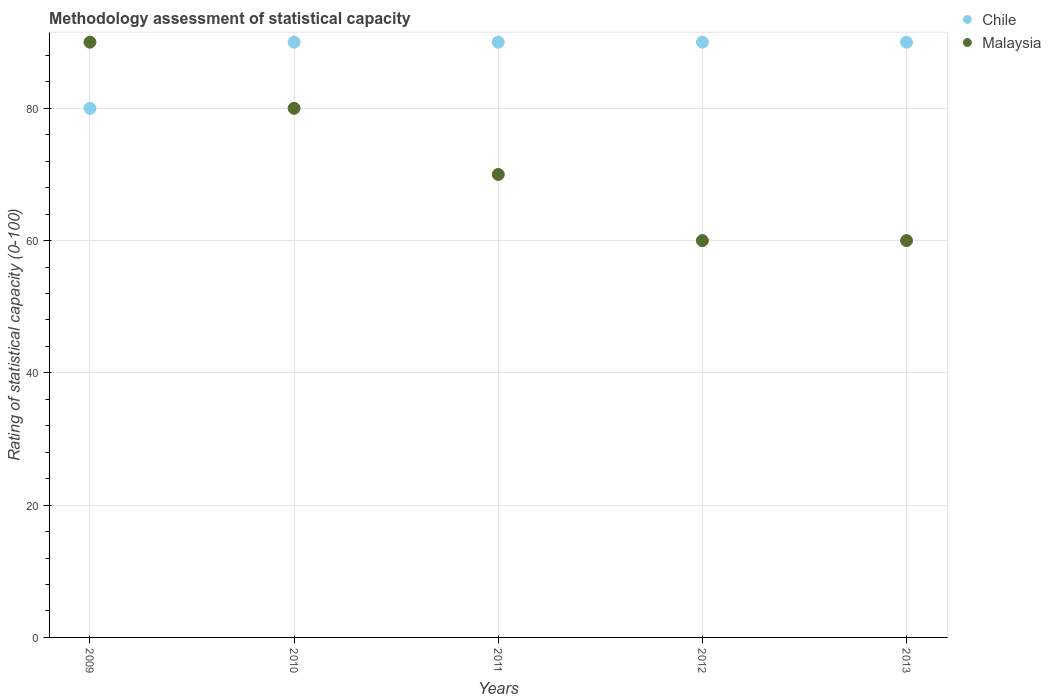How many different coloured dotlines are there?
Provide a succinct answer. 2. What is the rating of statistical capacity in Malaysia in 2011?
Keep it short and to the point. 70. Across all years, what is the maximum rating of statistical capacity in Malaysia?
Your answer should be very brief. 90. Across all years, what is the minimum rating of statistical capacity in Chile?
Ensure brevity in your answer.  80. In which year was the rating of statistical capacity in Malaysia maximum?
Ensure brevity in your answer.  2009. In which year was the rating of statistical capacity in Chile minimum?
Your answer should be very brief. 2009. What is the total rating of statistical capacity in Chile in the graph?
Give a very brief answer. 440. In the year 2011, what is the difference between the rating of statistical capacity in Chile and rating of statistical capacity in Malaysia?
Ensure brevity in your answer.  20. In how many years, is the rating of statistical capacity in Chile greater than 72?
Make the answer very short. 5. What is the ratio of the rating of statistical capacity in Chile in 2010 to that in 2013?
Provide a succinct answer. 1. Is the difference between the rating of statistical capacity in Chile in 2009 and 2012 greater than the difference between the rating of statistical capacity in Malaysia in 2009 and 2012?
Keep it short and to the point. No. What is the difference between the highest and the second highest rating of statistical capacity in Malaysia?
Give a very brief answer. 10. What is the difference between the highest and the lowest rating of statistical capacity in Chile?
Provide a succinct answer. 10. Is the sum of the rating of statistical capacity in Chile in 2009 and 2011 greater than the maximum rating of statistical capacity in Malaysia across all years?
Provide a succinct answer. Yes. Is the rating of statistical capacity in Malaysia strictly less than the rating of statistical capacity in Chile over the years?
Give a very brief answer. No. How many dotlines are there?
Provide a short and direct response. 2. Does the graph contain any zero values?
Give a very brief answer. No. Where does the legend appear in the graph?
Your answer should be very brief. Top right. How many legend labels are there?
Offer a terse response. 2. What is the title of the graph?
Make the answer very short. Methodology assessment of statistical capacity. Does "Burkina Faso" appear as one of the legend labels in the graph?
Your answer should be very brief. No. What is the label or title of the X-axis?
Give a very brief answer. Years. What is the label or title of the Y-axis?
Keep it short and to the point. Rating of statistical capacity (0-100). What is the Rating of statistical capacity (0-100) in Chile in 2009?
Your answer should be very brief. 80. What is the Rating of statistical capacity (0-100) in Malaysia in 2009?
Your answer should be very brief. 90. What is the Rating of statistical capacity (0-100) of Malaysia in 2010?
Ensure brevity in your answer.  80. What is the Rating of statistical capacity (0-100) in Malaysia in 2013?
Your answer should be very brief. 60. What is the total Rating of statistical capacity (0-100) of Chile in the graph?
Ensure brevity in your answer.  440. What is the total Rating of statistical capacity (0-100) of Malaysia in the graph?
Offer a very short reply. 360. What is the difference between the Rating of statistical capacity (0-100) of Malaysia in 2009 and that in 2010?
Give a very brief answer. 10. What is the difference between the Rating of statistical capacity (0-100) in Malaysia in 2009 and that in 2012?
Your answer should be very brief. 30. What is the difference between the Rating of statistical capacity (0-100) in Malaysia in 2009 and that in 2013?
Provide a succinct answer. 30. What is the difference between the Rating of statistical capacity (0-100) in Malaysia in 2010 and that in 2011?
Keep it short and to the point. 10. What is the difference between the Rating of statistical capacity (0-100) in Malaysia in 2010 and that in 2013?
Offer a very short reply. 20. What is the difference between the Rating of statistical capacity (0-100) of Chile in 2011 and that in 2013?
Make the answer very short. 0. What is the difference between the Rating of statistical capacity (0-100) in Malaysia in 2012 and that in 2013?
Your answer should be very brief. 0. What is the difference between the Rating of statistical capacity (0-100) in Chile in 2010 and the Rating of statistical capacity (0-100) in Malaysia in 2013?
Provide a succinct answer. 30. What is the difference between the Rating of statistical capacity (0-100) in Chile in 2011 and the Rating of statistical capacity (0-100) in Malaysia in 2012?
Give a very brief answer. 30. In the year 2009, what is the difference between the Rating of statistical capacity (0-100) of Chile and Rating of statistical capacity (0-100) of Malaysia?
Ensure brevity in your answer.  -10. In the year 2013, what is the difference between the Rating of statistical capacity (0-100) in Chile and Rating of statistical capacity (0-100) in Malaysia?
Offer a terse response. 30. What is the ratio of the Rating of statistical capacity (0-100) of Malaysia in 2009 to that in 2012?
Ensure brevity in your answer.  1.5. What is the ratio of the Rating of statistical capacity (0-100) of Chile in 2009 to that in 2013?
Provide a short and direct response. 0.89. What is the ratio of the Rating of statistical capacity (0-100) of Chile in 2010 to that in 2011?
Ensure brevity in your answer.  1. What is the ratio of the Rating of statistical capacity (0-100) of Chile in 2010 to that in 2012?
Provide a succinct answer. 1. What is the ratio of the Rating of statistical capacity (0-100) of Chile in 2010 to that in 2013?
Offer a terse response. 1. What is the ratio of the Rating of statistical capacity (0-100) of Malaysia in 2010 to that in 2013?
Make the answer very short. 1.33. What is the ratio of the Rating of statistical capacity (0-100) of Malaysia in 2011 to that in 2012?
Provide a succinct answer. 1.17. What is the ratio of the Rating of statistical capacity (0-100) of Malaysia in 2011 to that in 2013?
Offer a very short reply. 1.17. What is the ratio of the Rating of statistical capacity (0-100) of Chile in 2012 to that in 2013?
Provide a short and direct response. 1. What is the difference between the highest and the lowest Rating of statistical capacity (0-100) of Chile?
Provide a short and direct response. 10. 